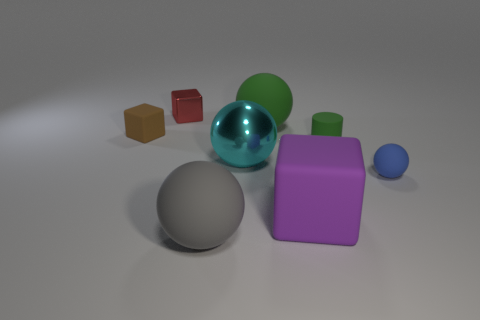Subtract all red cubes. How many cubes are left? 2 Subtract all purple blocks. How many blocks are left? 2 Subtract all cylinders. How many objects are left? 7 Subtract 1 cylinders. How many cylinders are left? 0 Add 2 purple blocks. How many objects exist? 10 Subtract all purple cubes. Subtract all green cylinders. How many cubes are left? 2 Subtract all large gray metallic cubes. Subtract all brown things. How many objects are left? 7 Add 3 big gray things. How many big gray things are left? 4 Add 3 tiny blue shiny spheres. How many tiny blue shiny spheres exist? 3 Subtract 0 cyan cylinders. How many objects are left? 8 